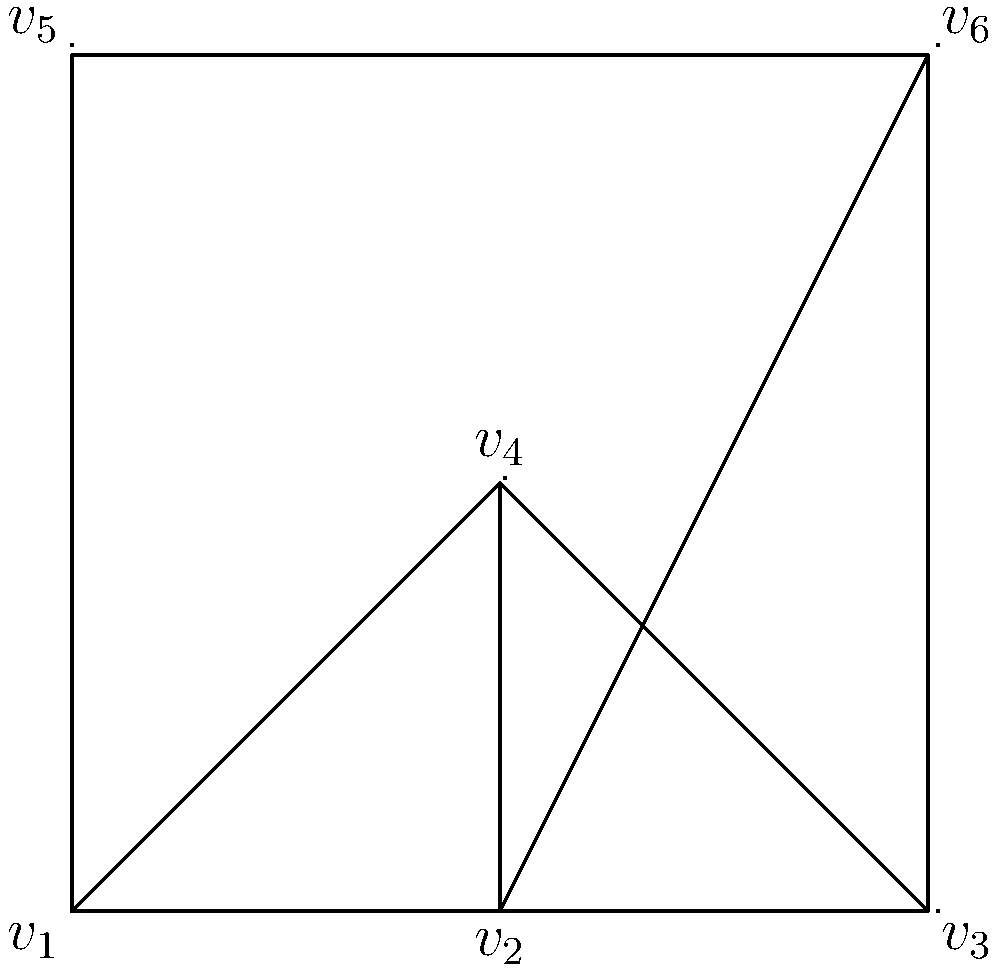Consider the planar graph shown above. What is the chromatic number of this graph, and how does it relate to the Four Color Theorem? Provide a brief justification for your answer. To determine the chromatic number of the given planar graph, we follow these steps:

1. Observe the graph:
   The graph is planar and has 6 vertices.

2. Count the colors used:
   We can see that 4 colors (red, green, blue, and yellow) are used to color the vertices.

3. Verify the proper coloring:
   - No two adjacent vertices share the same color.
   - This coloring is valid and uses 4 colors.

4. Consider the Four Color Theorem:
   The Four Color Theorem states that any planar graph can be colored using at most 4 colors.

5. Determine the chromatic number:
   - The chromatic number is the minimum number of colors needed for a proper coloring.
   - We have a valid 4-coloring, so the chromatic number is at most 4.
   - The graph contains a complete subgraph of 4 vertices (e.g., $v_1$, $v_2$, $v_3$, and $v_4$), which requires at least 4 colors.

6. Relate to the Four Color Theorem:
   - The chromatic number of this graph (4) matches the upper bound given by the Four Color Theorem.
   - This graph is an example where the maximum number of colors allowed by the theorem is actually necessary.

Therefore, the chromatic number of this graph is 4, which is consistent with the Four Color Theorem. This example demonstrates a case where the theorem's upper bound is tight.
Answer: The chromatic number is 4, matching the Four Color Theorem's upper bound. 